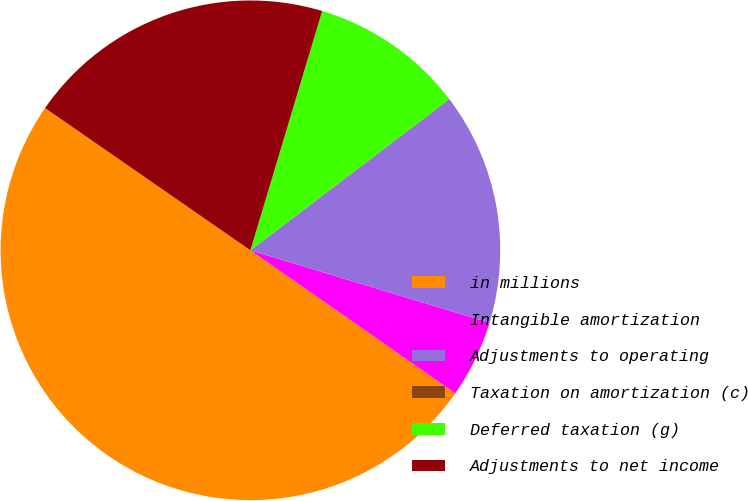Convert chart. <chart><loc_0><loc_0><loc_500><loc_500><pie_chart><fcel>in millions<fcel>Intangible amortization<fcel>Adjustments to operating<fcel>Taxation on amortization (c)<fcel>Deferred taxation (g)<fcel>Adjustments to net income<nl><fcel>49.94%<fcel>5.02%<fcel>15.0%<fcel>0.03%<fcel>10.01%<fcel>19.99%<nl></chart> 